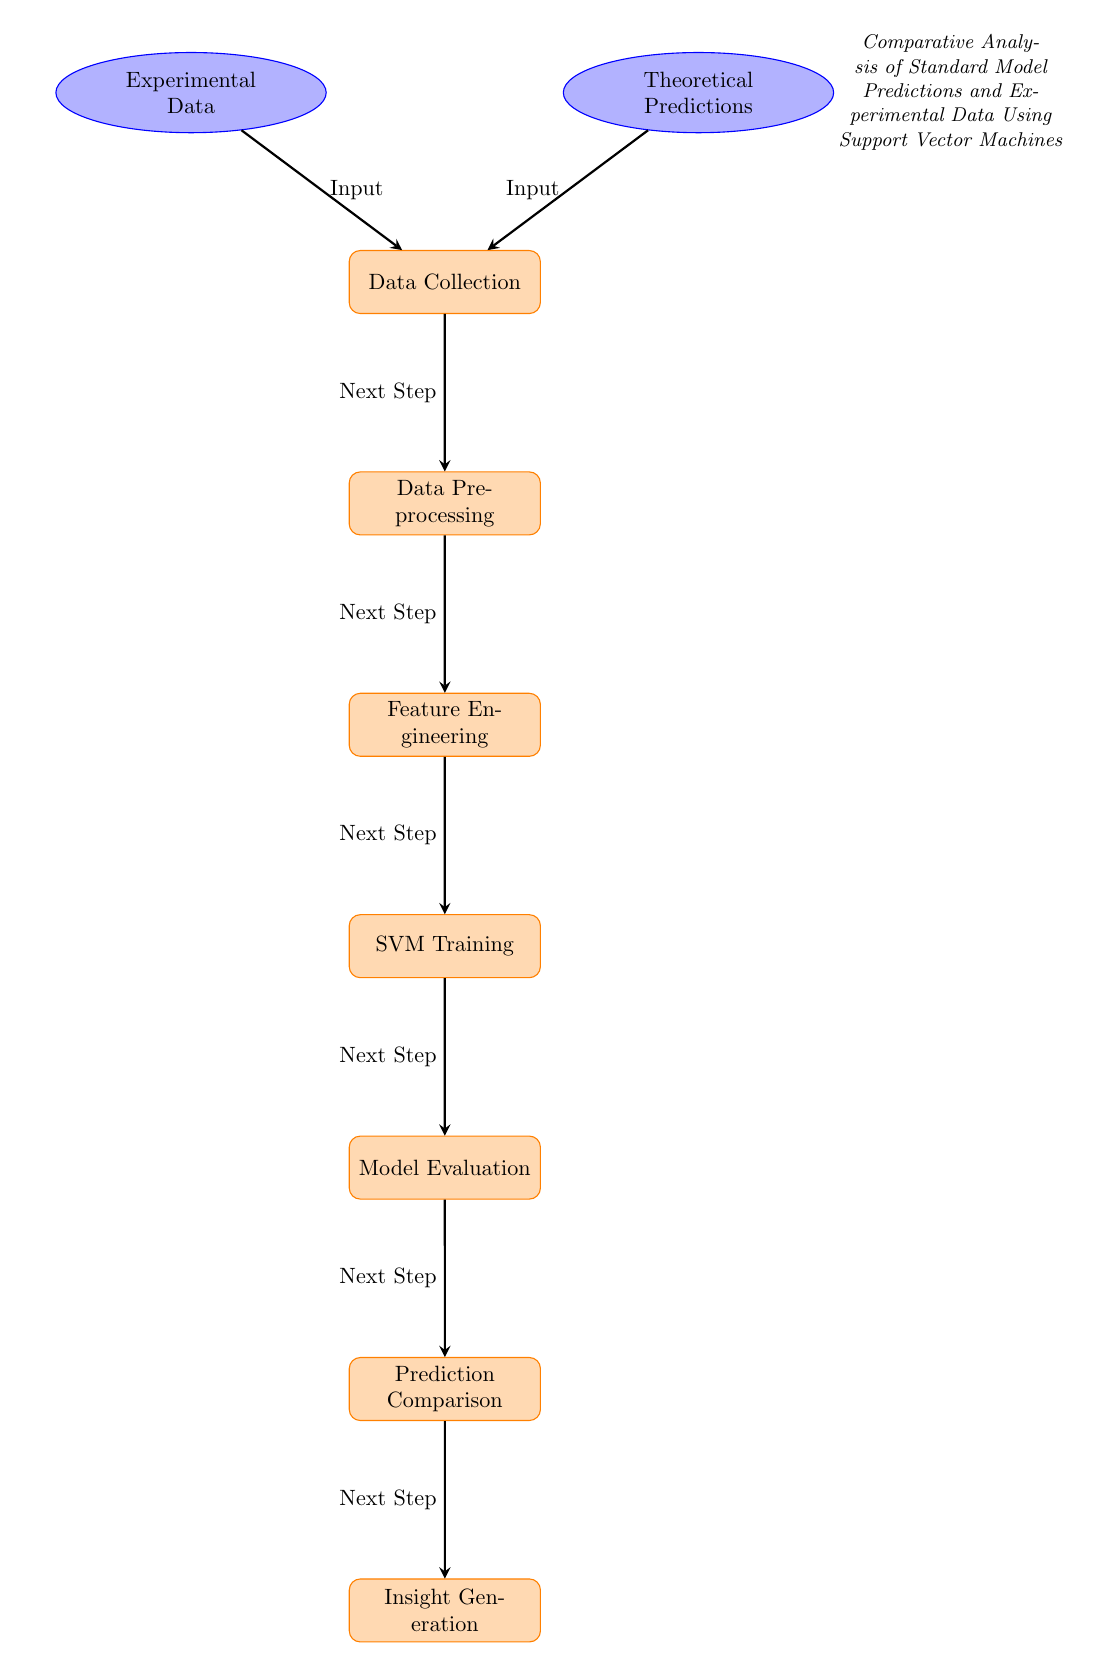What are the two main types of input in this diagram? The diagram indicates two distinct input types, which are represented by the nodes for "Experimental Data" and "Theoretical Predictions." These nodes are connected to the "Data Collection" process, showing that both types of input feed into this step.
Answer: Experimental Data and Theoretical Predictions How many processes are there in the diagram? There are seven processes in the diagram: Data Collection, Data Preprocessing, Feature Engineering, SVM Training, Model Evaluation, Prediction Comparison, and Insight Generation. These processes are represented as rectangular nodes connected by arrows.
Answer: Seven What is the final step in the flow of the diagram? The final step in the flow of the diagram is "Insight Generation." It is located at the bottom of the diagram and follows the "Prediction Comparison" step, indicating that insights are generated after comparing predictions.
Answer: Insight Generation Which node receives input from both Experimental Data and Theoretical Predictions? The "Data Collection" node receives input from both the "Experimental Data" node on the left and the "Theoretical Predictions" node on the right, as evidenced by the arrows pointing from both input nodes to this process node.
Answer: Data Collection What is the step that directly follows Model Evaluation? The step that directly follows "Model Evaluation" in the flow of the diagram is "Prediction Comparison." It is indicated by an arrow leading from the "Model Evaluation" node to the "Prediction Comparison" node, showing the sequence of the processes.
Answer: Prediction Comparison How many edges (arrows) are present in the diagram? The diagram contains six arrows connecting the processes and input nodes, signifying the flow of data and steps between the various elements involved in the analysis.
Answer: Six What is indicated as the purpose of the diagram in the top right? The upper right of the diagram contains the phrase "Comparative Analysis of Standard Model Predictions and Experimental Data Using Support Vector Machines," indicating that this is the overarching purpose of the entire flow represented.
Answer: Comparative Analysis of Standard Model Predictions and Experimental Data Using Support Vector Machines 